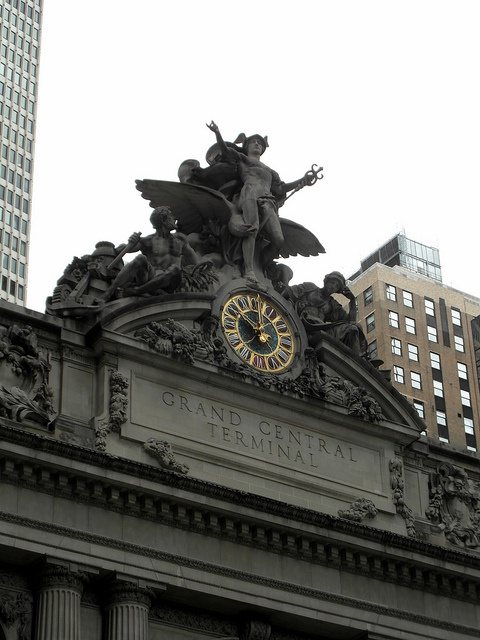Describe the objects in this image and their specific colors. I can see a clock in ivory, black, gray, and tan tones in this image. 